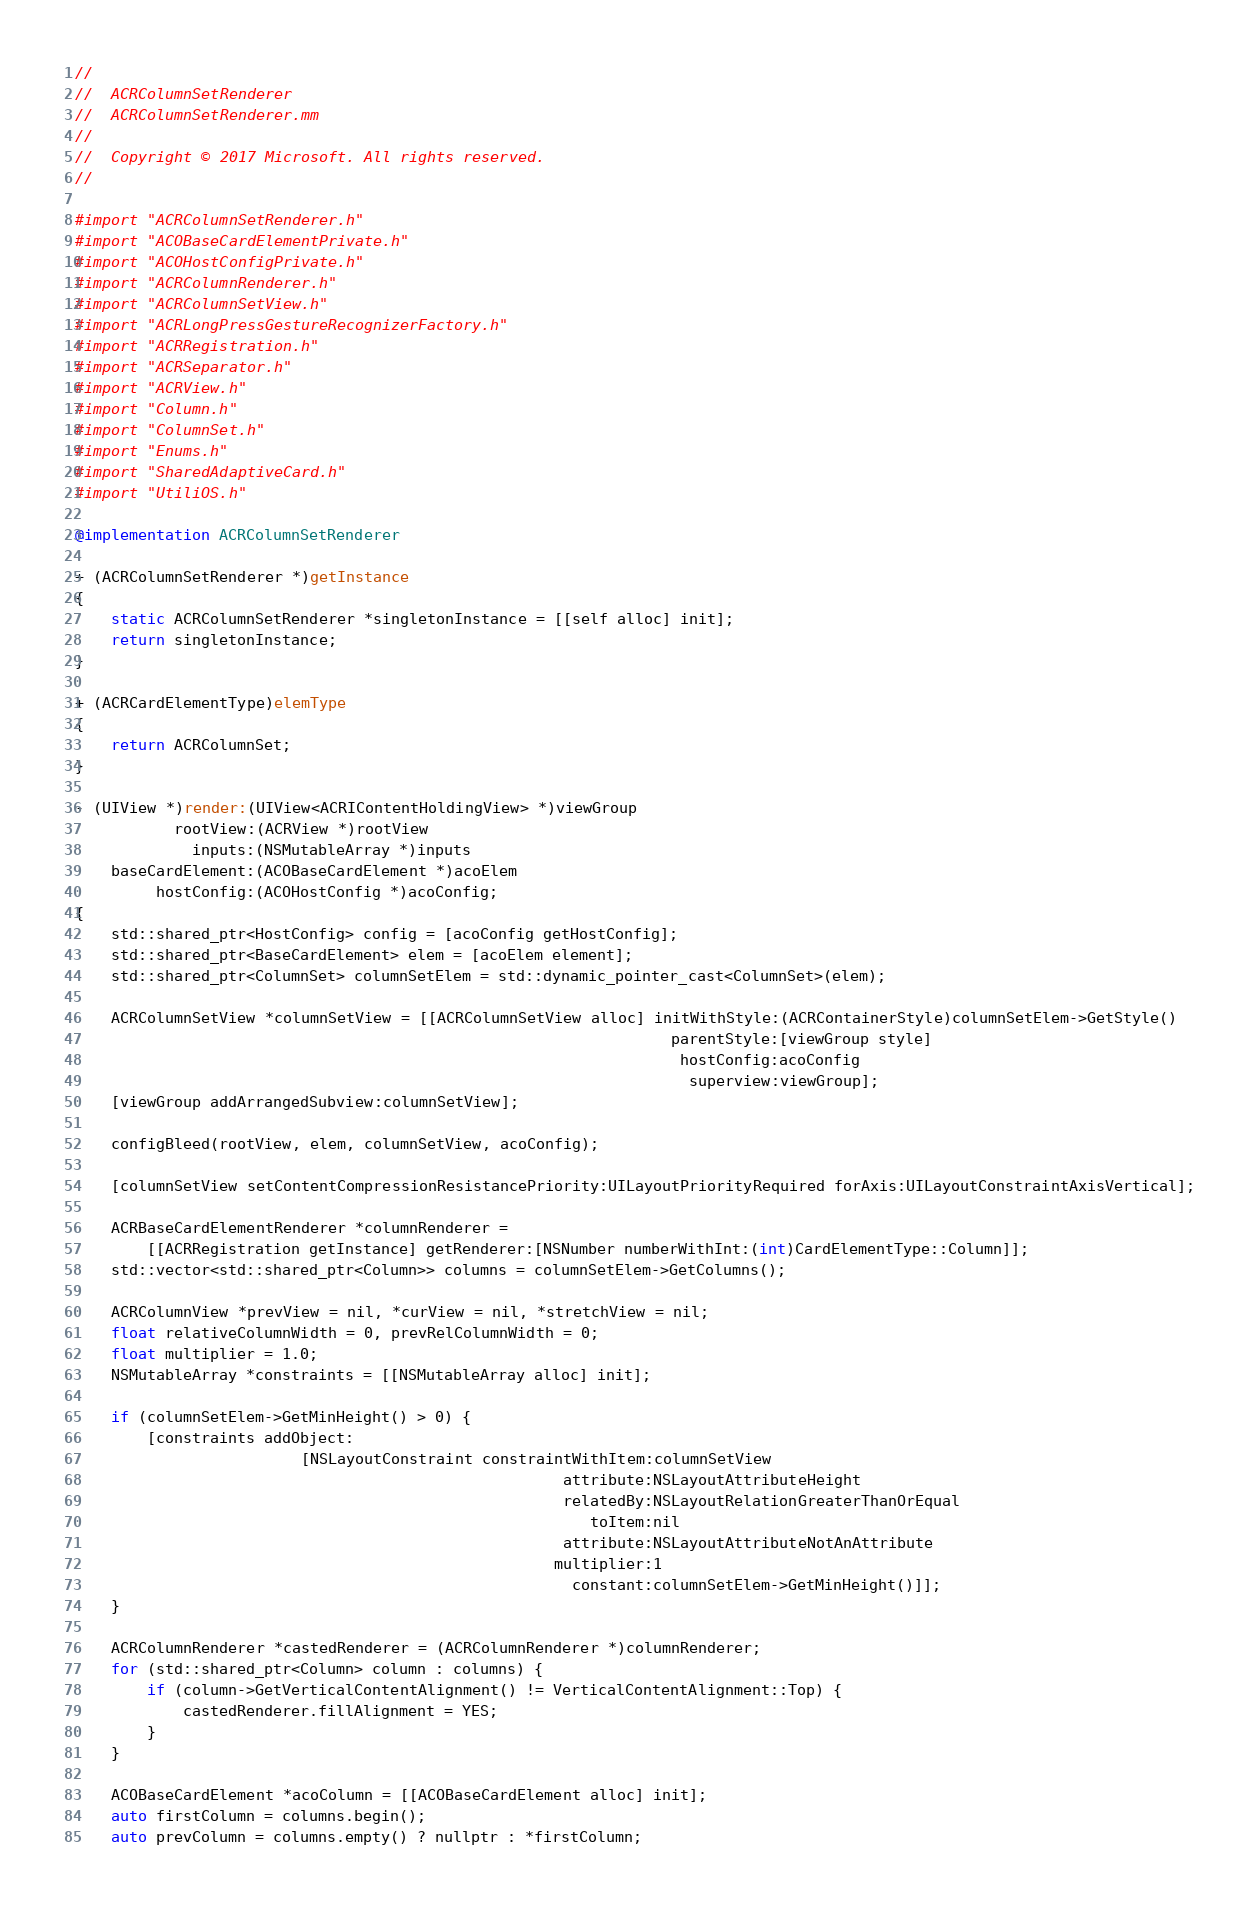<code> <loc_0><loc_0><loc_500><loc_500><_ObjectiveC_>//
//  ACRColumnSetRenderer
//  ACRColumnSetRenderer.mm
//
//  Copyright © 2017 Microsoft. All rights reserved.
//

#import "ACRColumnSetRenderer.h"
#import "ACOBaseCardElementPrivate.h"
#import "ACOHostConfigPrivate.h"
#import "ACRColumnRenderer.h"
#import "ACRColumnSetView.h"
#import "ACRLongPressGestureRecognizerFactory.h"
#import "ACRRegistration.h"
#import "ACRSeparator.h"
#import "ACRView.h"
#import "Column.h"
#import "ColumnSet.h"
#import "Enums.h"
#import "SharedAdaptiveCard.h"
#import "UtiliOS.h"

@implementation ACRColumnSetRenderer

+ (ACRColumnSetRenderer *)getInstance
{
    static ACRColumnSetRenderer *singletonInstance = [[self alloc] init];
    return singletonInstance;
}

+ (ACRCardElementType)elemType
{
    return ACRColumnSet;
}

- (UIView *)render:(UIView<ACRIContentHoldingView> *)viewGroup
           rootView:(ACRView *)rootView
             inputs:(NSMutableArray *)inputs
    baseCardElement:(ACOBaseCardElement *)acoElem
         hostConfig:(ACOHostConfig *)acoConfig;
{
    std::shared_ptr<HostConfig> config = [acoConfig getHostConfig];
    std::shared_ptr<BaseCardElement> elem = [acoElem element];
    std::shared_ptr<ColumnSet> columnSetElem = std::dynamic_pointer_cast<ColumnSet>(elem);

    ACRColumnSetView *columnSetView = [[ACRColumnSetView alloc] initWithStyle:(ACRContainerStyle)columnSetElem->GetStyle()
                                                                  parentStyle:[viewGroup style]
                                                                   hostConfig:acoConfig
                                                                    superview:viewGroup];
    [viewGroup addArrangedSubview:columnSetView];

    configBleed(rootView, elem, columnSetView, acoConfig);

    [columnSetView setContentCompressionResistancePriority:UILayoutPriorityRequired forAxis:UILayoutConstraintAxisVertical];

    ACRBaseCardElementRenderer *columnRenderer =
        [[ACRRegistration getInstance] getRenderer:[NSNumber numberWithInt:(int)CardElementType::Column]];
    std::vector<std::shared_ptr<Column>> columns = columnSetElem->GetColumns();

    ACRColumnView *prevView = nil, *curView = nil, *stretchView = nil;
    float relativeColumnWidth = 0, prevRelColumnWidth = 0;
    float multiplier = 1.0;
    NSMutableArray *constraints = [[NSMutableArray alloc] init];

    if (columnSetElem->GetMinHeight() > 0) {
        [constraints addObject:
                         [NSLayoutConstraint constraintWithItem:columnSetView
                                                      attribute:NSLayoutAttributeHeight
                                                      relatedBy:NSLayoutRelationGreaterThanOrEqual
                                                         toItem:nil
                                                      attribute:NSLayoutAttributeNotAnAttribute
                                                     multiplier:1
                                                       constant:columnSetElem->GetMinHeight()]];
    }

    ACRColumnRenderer *castedRenderer = (ACRColumnRenderer *)columnRenderer;
    for (std::shared_ptr<Column> column : columns) {
        if (column->GetVerticalContentAlignment() != VerticalContentAlignment::Top) {
            castedRenderer.fillAlignment = YES;
        }
    }

    ACOBaseCardElement *acoColumn = [[ACOBaseCardElement alloc] init];
    auto firstColumn = columns.begin();
    auto prevColumn = columns.empty() ? nullptr : *firstColumn;</code> 